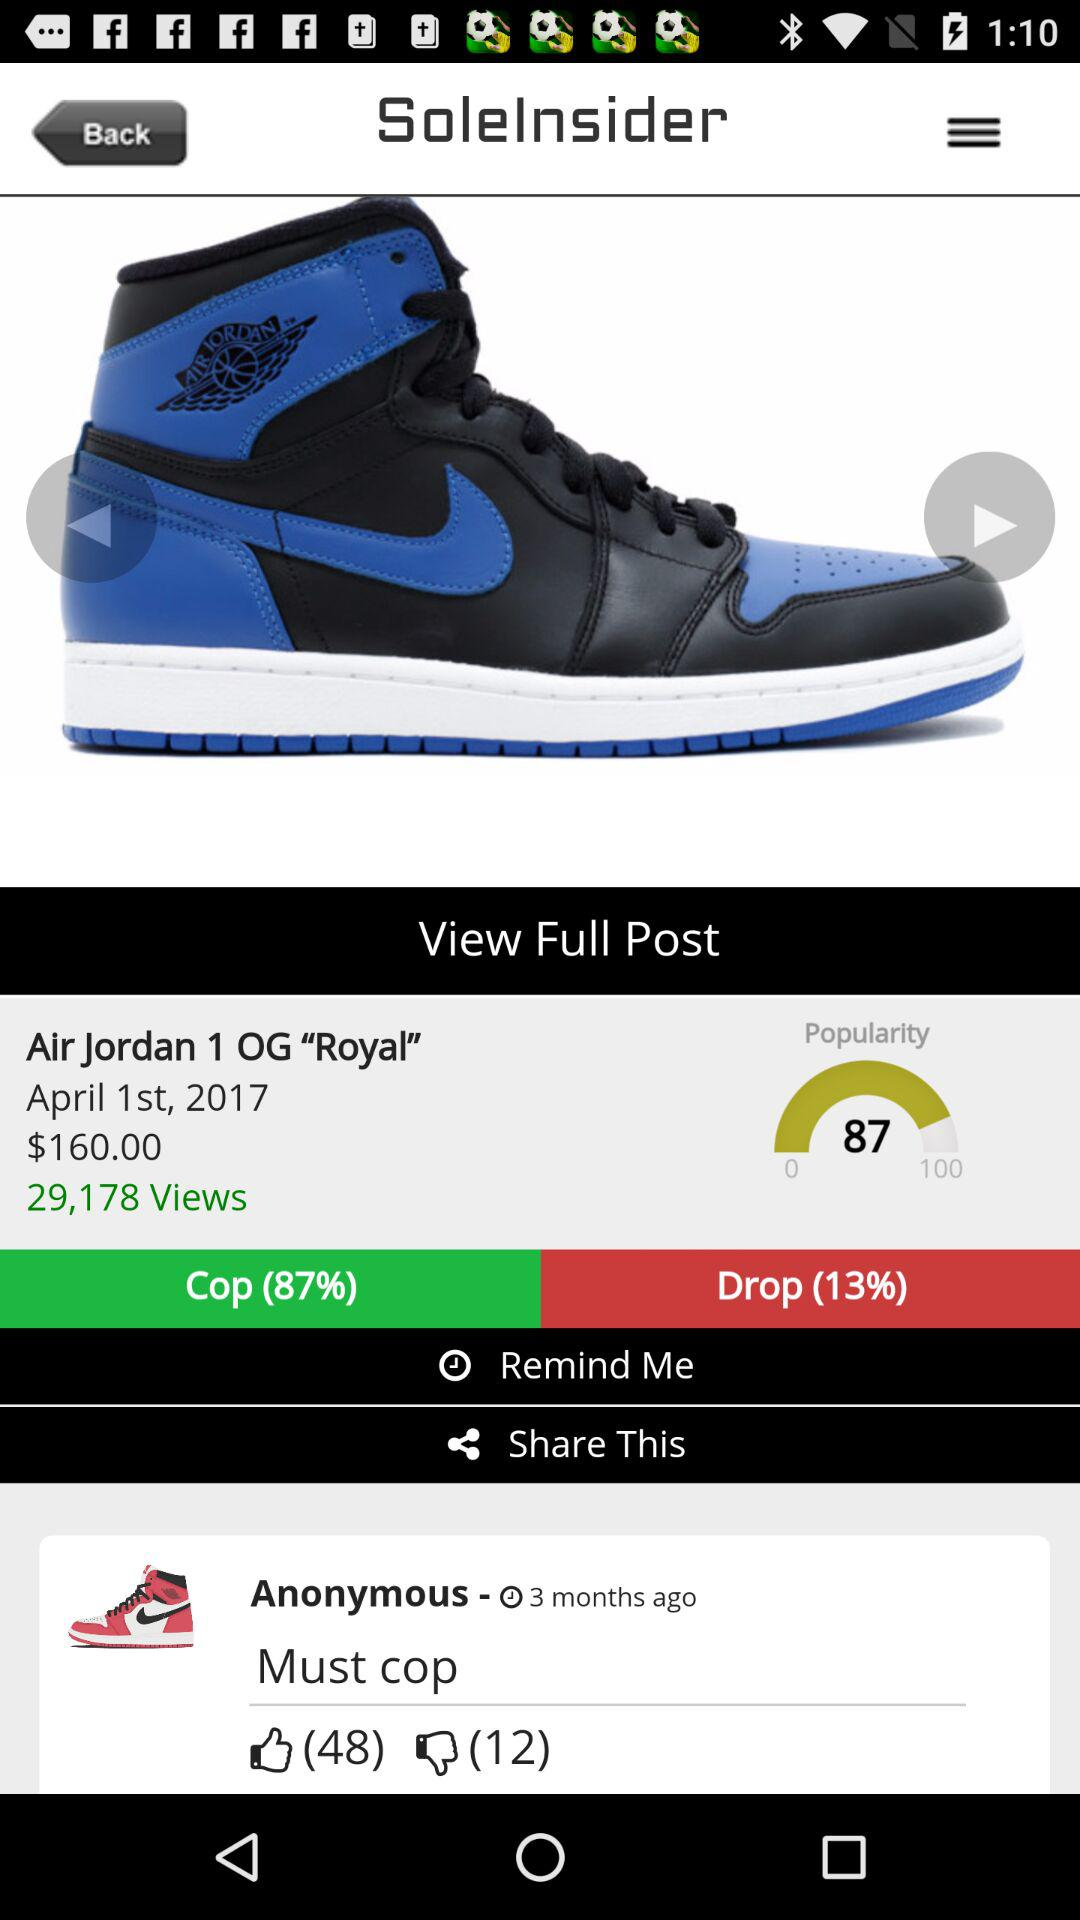What is the drop percentage of the "Air Jordan 1 OG "Royal""? The drop percentage of the "Air Jordan 1 OG "Royal"" is 13. 